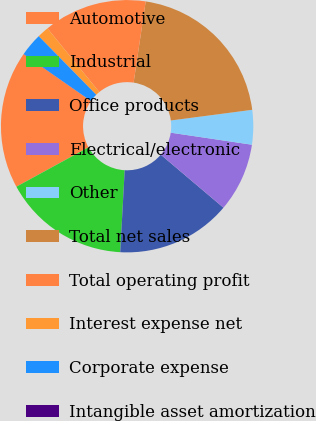Convert chart to OTSL. <chart><loc_0><loc_0><loc_500><loc_500><pie_chart><fcel>Automotive<fcel>Industrial<fcel>Office products<fcel>Electrical/electronic<fcel>Other<fcel>Total net sales<fcel>Total operating profit<fcel>Interest expense net<fcel>Corporate expense<fcel>Intangible asset amortization<nl><fcel>17.64%<fcel>16.17%<fcel>14.7%<fcel>8.83%<fcel>4.42%<fcel>20.57%<fcel>13.23%<fcel>1.48%<fcel>2.95%<fcel>0.01%<nl></chart> 